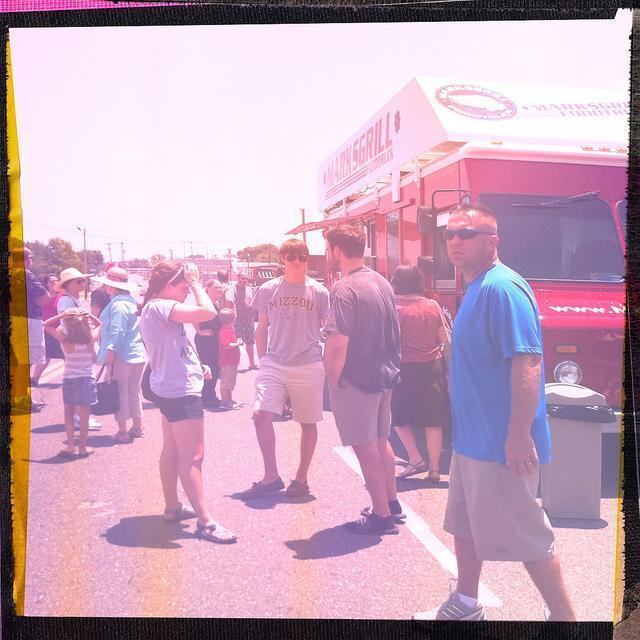How many people are in the picture?
Give a very brief answer. 9. How many train cars are there?
Give a very brief answer. 0. 